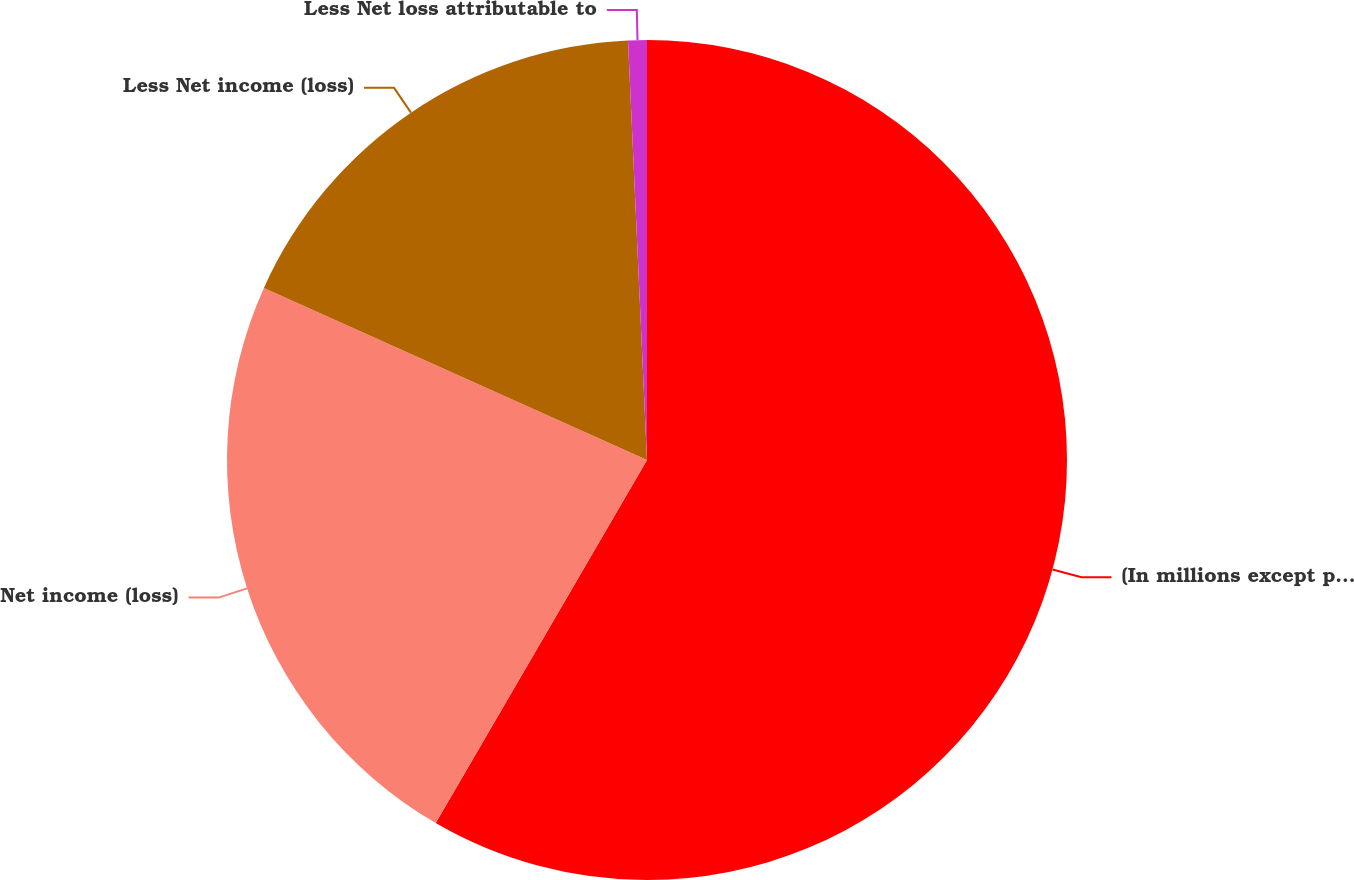Convert chart to OTSL. <chart><loc_0><loc_0><loc_500><loc_500><pie_chart><fcel>(In millions except per share<fcel>Net income (loss)<fcel>Less Net income (loss)<fcel>Less Net loss attributable to<nl><fcel>58.39%<fcel>23.33%<fcel>17.56%<fcel>0.72%<nl></chart> 